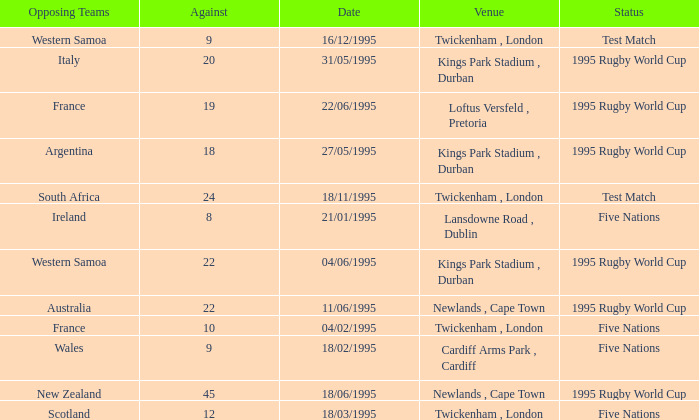What's the status on 16/12/1995? Test Match. Would you be able to parse every entry in this table? {'header': ['Opposing Teams', 'Against', 'Date', 'Venue', 'Status'], 'rows': [['Western Samoa', '9', '16/12/1995', 'Twickenham , London', 'Test Match'], ['Italy', '20', '31/05/1995', 'Kings Park Stadium , Durban', '1995 Rugby World Cup'], ['France', '19', '22/06/1995', 'Loftus Versfeld , Pretoria', '1995 Rugby World Cup'], ['Argentina', '18', '27/05/1995', 'Kings Park Stadium , Durban', '1995 Rugby World Cup'], ['South Africa', '24', '18/11/1995', 'Twickenham , London', 'Test Match'], ['Ireland', '8', '21/01/1995', 'Lansdowne Road , Dublin', 'Five Nations'], ['Western Samoa', '22', '04/06/1995', 'Kings Park Stadium , Durban', '1995 Rugby World Cup'], ['Australia', '22', '11/06/1995', 'Newlands , Cape Town', '1995 Rugby World Cup'], ['France', '10', '04/02/1995', 'Twickenham , London', 'Five Nations'], ['Wales', '9', '18/02/1995', 'Cardiff Arms Park , Cardiff', 'Five Nations'], ['New Zealand', '45', '18/06/1995', 'Newlands , Cape Town', '1995 Rugby World Cup'], ['Scotland', '12', '18/03/1995', 'Twickenham , London', 'Five Nations']]} 